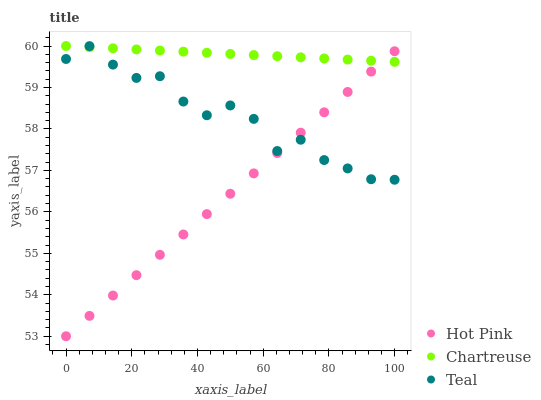Does Hot Pink have the minimum area under the curve?
Answer yes or no. Yes. Does Chartreuse have the maximum area under the curve?
Answer yes or no. Yes. Does Teal have the minimum area under the curve?
Answer yes or no. No. Does Teal have the maximum area under the curve?
Answer yes or no. No. Is Hot Pink the smoothest?
Answer yes or no. Yes. Is Teal the roughest?
Answer yes or no. Yes. Is Teal the smoothest?
Answer yes or no. No. Is Hot Pink the roughest?
Answer yes or no. No. Does Hot Pink have the lowest value?
Answer yes or no. Yes. Does Teal have the lowest value?
Answer yes or no. No. Does Chartreuse have the highest value?
Answer yes or no. Yes. Does Teal have the highest value?
Answer yes or no. No. Does Chartreuse intersect Hot Pink?
Answer yes or no. Yes. Is Chartreuse less than Hot Pink?
Answer yes or no. No. Is Chartreuse greater than Hot Pink?
Answer yes or no. No. 